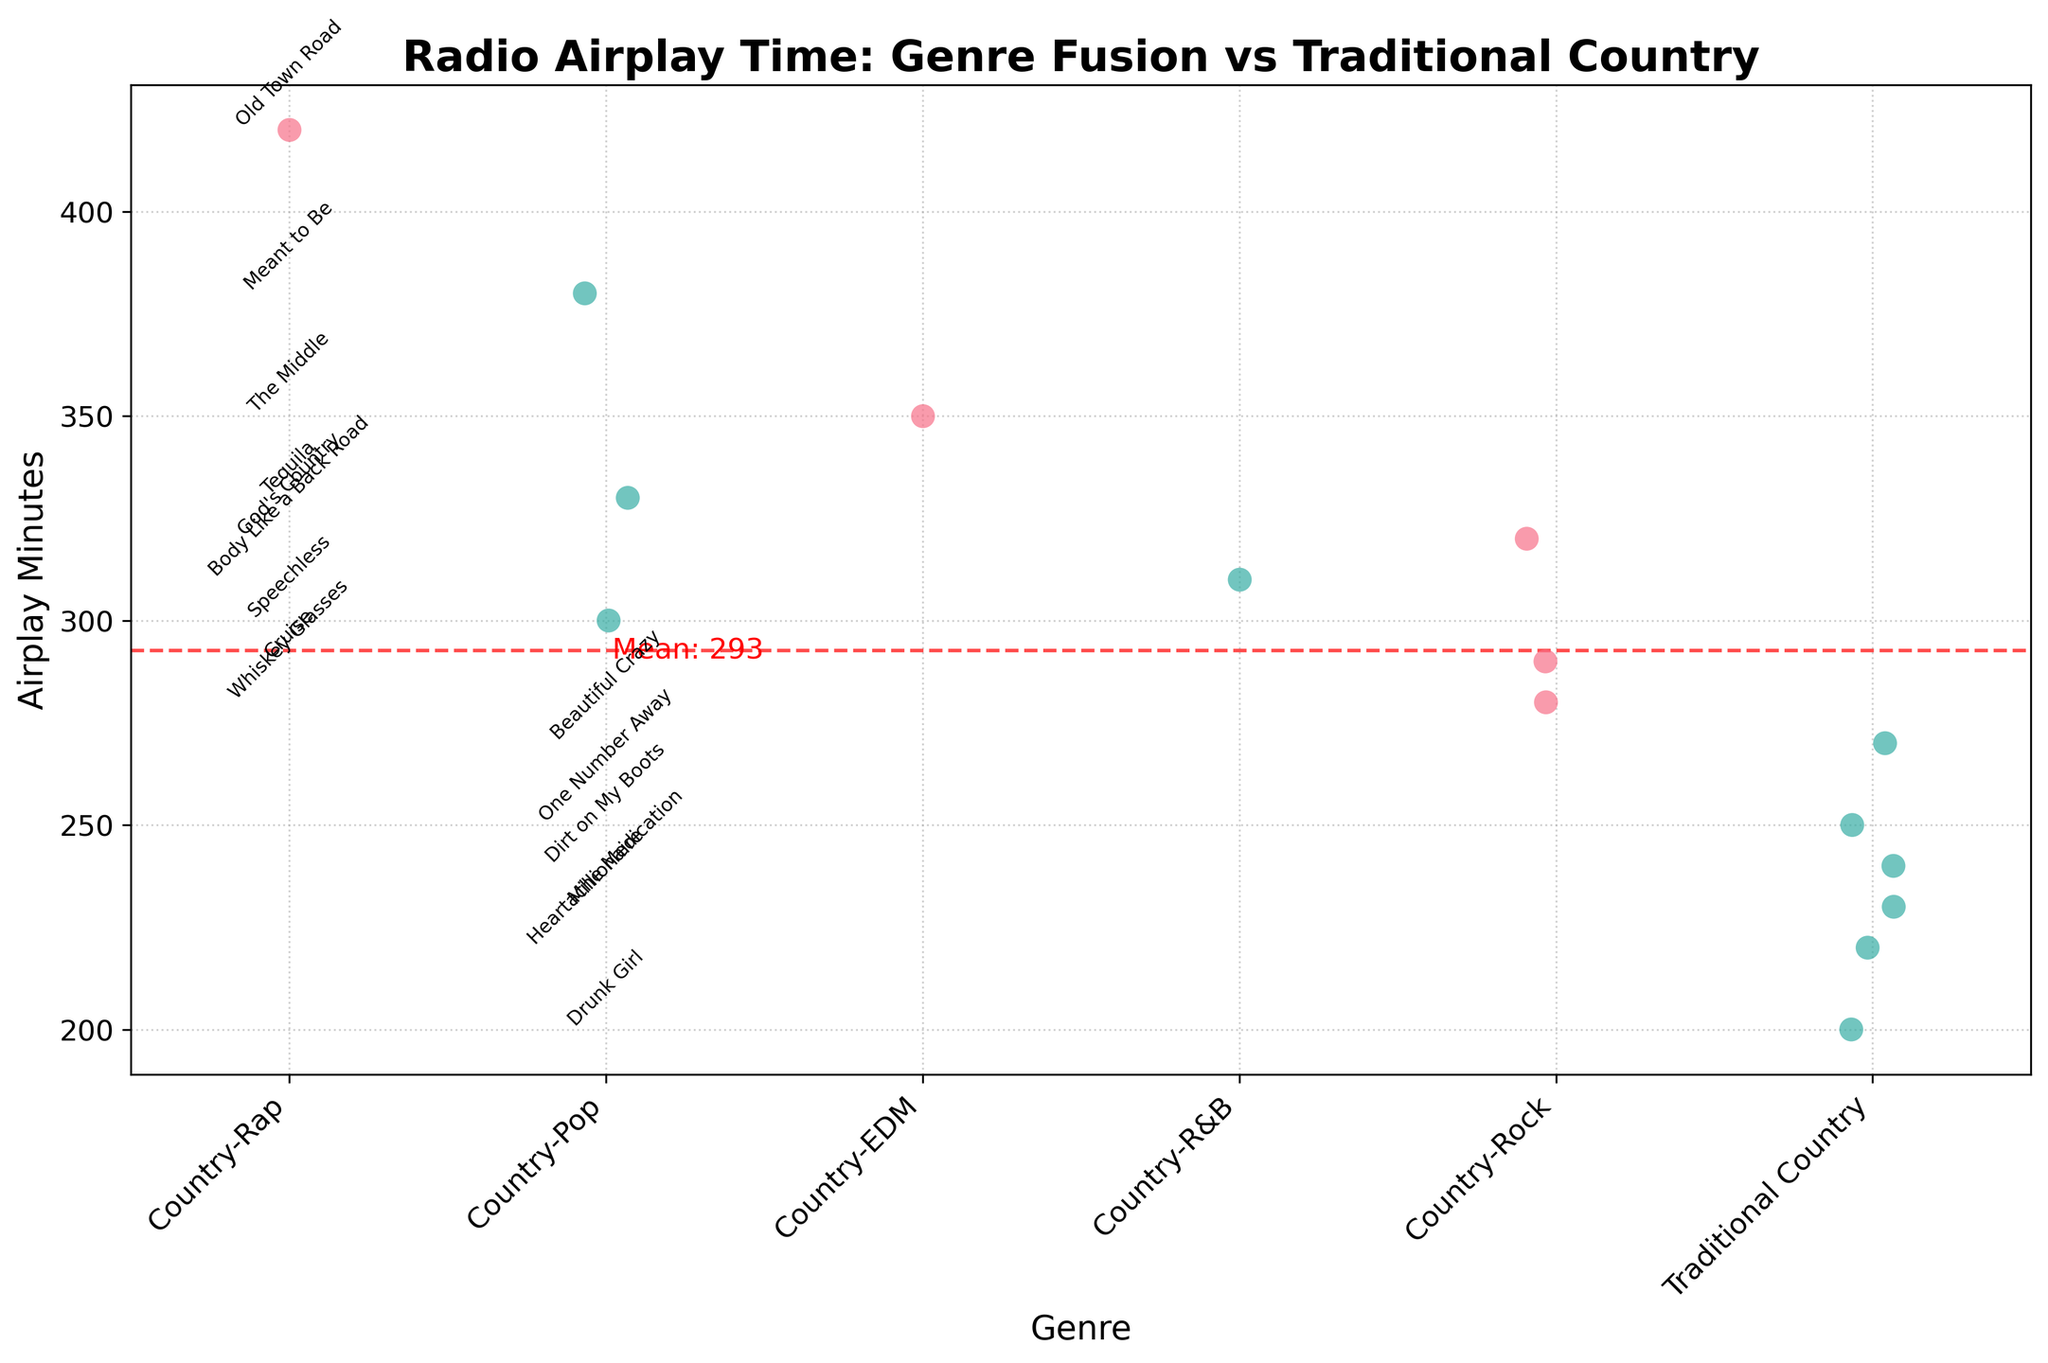What is the title of the figure? The title of the figure is usually placed at the top and is meant to provide a summary of what the chart is about. In this strip plot, the title tells us that the plot illustrates "Radio Airplay Time: Genre Fusion vs Traditional Country".
Answer: Radio Airplay Time: Genre Fusion vs Traditional Country How many categories of genres are displayed on the x-axis? The x-axis shows the different categories being compared. In this case, it shows the genre fusion types, which are two: "Genre Fusion" and "Traditional Country". This can be observed by looking at the labels on the x-axis.
Answer: 2 What does the red dashed line represent in the plot? The red dashed line typically signifies a statistical measure. Here, it represents the mean airplay time across all songs. This can be inferred from the label next to the line which states 'Mean'.
Answer: The mean airplay time Which genre category generally has higher airplay times? By comparing the vertical distribution of points (airplay times) in each category, one can see if one category tends to have higher values. The genre fusion category has points that are generally distributed at higher values than traditional country.
Answer: Genre Fusion What is the mean airplay time as indicated on the figure? The mean airplay time is indicated by the position of the red dashed line and its corresponding label. The precise value is written next to the line in the figure.
Answer: 288 minutes How many traditional country songs have airplay times above the mean? To determine this, count the number of points in the traditional country category that are above the red dashed line. By visual inspection, three points are above the mean line in the traditional country category.
Answer: 3 Which genre category has the highest individual airplay time and which song does it correspond to? The highest individual airplay time can be pinpointed as the topmost point in the plot. In the genre fusion category, "Old Town Road" by Lil Nas X has the highest airplay time.
Answer: Genre Fusion, "Old Town Road" What is the airplay time for "Body Like a Back Road"? Locate the point labeled "Body Like a Back Road" within the genre fusion category and read its corresponding airplay time on the y-axis.
Answer: 310 minutes What is the airplay time difference between the song with the highest airplay and the song with the lowest airplay? The highest airplay time is 420 minutes for "Old Town Road," and the lowest airplay time is 200 minutes for "Drunk Girl." The difference can be calculated by subtracting the lowest from the highest. 420 - 200 = 220
Answer: 220 minutes 